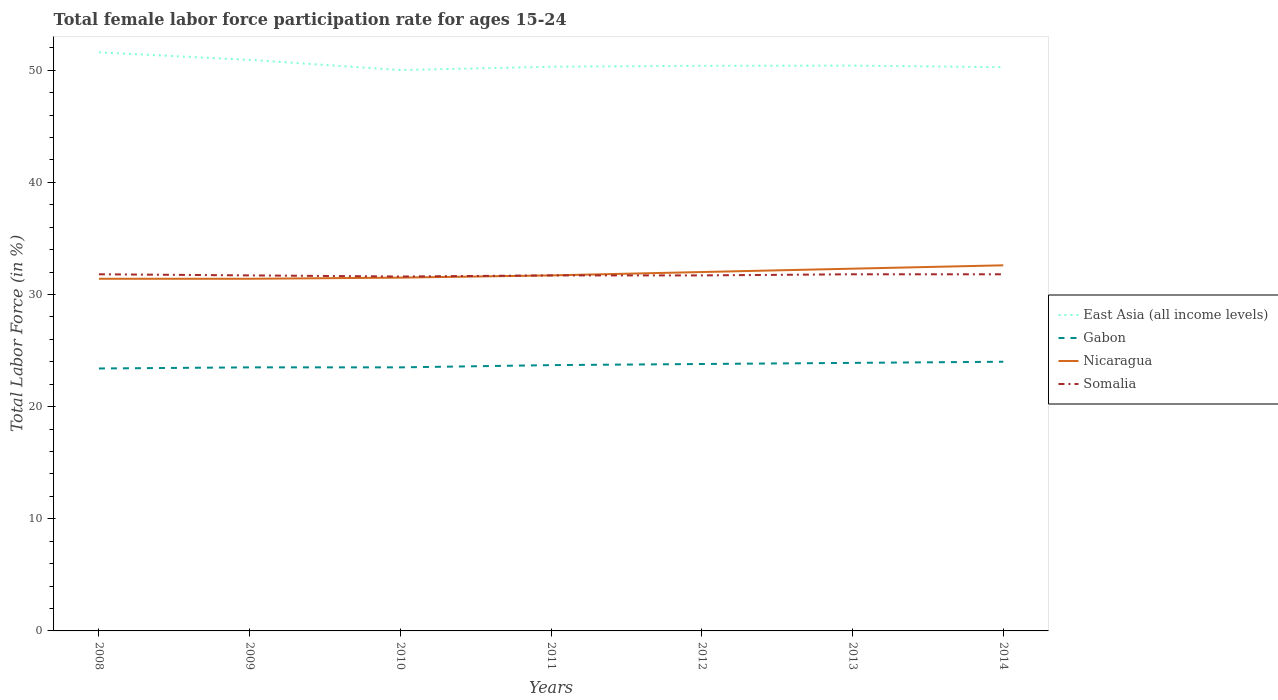Is the number of lines equal to the number of legend labels?
Offer a terse response. Yes. Across all years, what is the maximum female labor force participation rate in East Asia (all income levels)?
Keep it short and to the point. 50.01. In which year was the female labor force participation rate in Gabon maximum?
Make the answer very short. 2008. What is the total female labor force participation rate in East Asia (all income levels) in the graph?
Ensure brevity in your answer.  1.19. What is the difference between the highest and the second highest female labor force participation rate in Somalia?
Keep it short and to the point. 0.2. What is the difference between the highest and the lowest female labor force participation rate in Somalia?
Ensure brevity in your answer.  3. Is the female labor force participation rate in East Asia (all income levels) strictly greater than the female labor force participation rate in Gabon over the years?
Give a very brief answer. No. What is the difference between two consecutive major ticks on the Y-axis?
Offer a terse response. 10. Where does the legend appear in the graph?
Your answer should be compact. Center right. What is the title of the graph?
Make the answer very short. Total female labor force participation rate for ages 15-24. What is the label or title of the X-axis?
Keep it short and to the point. Years. What is the Total Labor Force (in %) in East Asia (all income levels) in 2008?
Offer a very short reply. 51.59. What is the Total Labor Force (in %) in Gabon in 2008?
Offer a very short reply. 23.4. What is the Total Labor Force (in %) in Nicaragua in 2008?
Provide a short and direct response. 31.4. What is the Total Labor Force (in %) in Somalia in 2008?
Keep it short and to the point. 31.8. What is the Total Labor Force (in %) of East Asia (all income levels) in 2009?
Make the answer very short. 50.92. What is the Total Labor Force (in %) of Nicaragua in 2009?
Keep it short and to the point. 31.4. What is the Total Labor Force (in %) in Somalia in 2009?
Your answer should be compact. 31.7. What is the Total Labor Force (in %) in East Asia (all income levels) in 2010?
Ensure brevity in your answer.  50.01. What is the Total Labor Force (in %) in Nicaragua in 2010?
Give a very brief answer. 31.5. What is the Total Labor Force (in %) in Somalia in 2010?
Provide a succinct answer. 31.6. What is the Total Labor Force (in %) of East Asia (all income levels) in 2011?
Offer a very short reply. 50.31. What is the Total Labor Force (in %) in Gabon in 2011?
Make the answer very short. 23.7. What is the Total Labor Force (in %) of Nicaragua in 2011?
Give a very brief answer. 31.7. What is the Total Labor Force (in %) in Somalia in 2011?
Make the answer very short. 31.7. What is the Total Labor Force (in %) in East Asia (all income levels) in 2012?
Ensure brevity in your answer.  50.39. What is the Total Labor Force (in %) in Gabon in 2012?
Offer a very short reply. 23.8. What is the Total Labor Force (in %) of Nicaragua in 2012?
Ensure brevity in your answer.  32. What is the Total Labor Force (in %) of Somalia in 2012?
Give a very brief answer. 31.7. What is the Total Labor Force (in %) of East Asia (all income levels) in 2013?
Your answer should be compact. 50.41. What is the Total Labor Force (in %) of Gabon in 2013?
Ensure brevity in your answer.  23.9. What is the Total Labor Force (in %) in Nicaragua in 2013?
Your answer should be very brief. 32.3. What is the Total Labor Force (in %) of Somalia in 2013?
Ensure brevity in your answer.  31.8. What is the Total Labor Force (in %) in East Asia (all income levels) in 2014?
Ensure brevity in your answer.  50.27. What is the Total Labor Force (in %) of Nicaragua in 2014?
Give a very brief answer. 32.6. What is the Total Labor Force (in %) of Somalia in 2014?
Your answer should be very brief. 31.8. Across all years, what is the maximum Total Labor Force (in %) in East Asia (all income levels)?
Your answer should be very brief. 51.59. Across all years, what is the maximum Total Labor Force (in %) in Nicaragua?
Your answer should be very brief. 32.6. Across all years, what is the maximum Total Labor Force (in %) of Somalia?
Provide a succinct answer. 31.8. Across all years, what is the minimum Total Labor Force (in %) of East Asia (all income levels)?
Offer a very short reply. 50.01. Across all years, what is the minimum Total Labor Force (in %) of Gabon?
Make the answer very short. 23.4. Across all years, what is the minimum Total Labor Force (in %) of Nicaragua?
Give a very brief answer. 31.4. Across all years, what is the minimum Total Labor Force (in %) in Somalia?
Offer a very short reply. 31.6. What is the total Total Labor Force (in %) in East Asia (all income levels) in the graph?
Make the answer very short. 353.88. What is the total Total Labor Force (in %) in Gabon in the graph?
Your response must be concise. 165.8. What is the total Total Labor Force (in %) of Nicaragua in the graph?
Give a very brief answer. 222.9. What is the total Total Labor Force (in %) in Somalia in the graph?
Provide a succinct answer. 222.1. What is the difference between the Total Labor Force (in %) in East Asia (all income levels) in 2008 and that in 2009?
Give a very brief answer. 0.67. What is the difference between the Total Labor Force (in %) in Gabon in 2008 and that in 2009?
Provide a succinct answer. -0.1. What is the difference between the Total Labor Force (in %) in Somalia in 2008 and that in 2009?
Your answer should be very brief. 0.1. What is the difference between the Total Labor Force (in %) of East Asia (all income levels) in 2008 and that in 2010?
Offer a terse response. 1.58. What is the difference between the Total Labor Force (in %) of Gabon in 2008 and that in 2010?
Your answer should be very brief. -0.1. What is the difference between the Total Labor Force (in %) in East Asia (all income levels) in 2008 and that in 2011?
Offer a very short reply. 1.28. What is the difference between the Total Labor Force (in %) of Gabon in 2008 and that in 2011?
Your answer should be compact. -0.3. What is the difference between the Total Labor Force (in %) of Nicaragua in 2008 and that in 2011?
Your answer should be very brief. -0.3. What is the difference between the Total Labor Force (in %) in East Asia (all income levels) in 2008 and that in 2012?
Offer a terse response. 1.19. What is the difference between the Total Labor Force (in %) of Nicaragua in 2008 and that in 2012?
Give a very brief answer. -0.6. What is the difference between the Total Labor Force (in %) in Somalia in 2008 and that in 2012?
Offer a terse response. 0.1. What is the difference between the Total Labor Force (in %) of East Asia (all income levels) in 2008 and that in 2013?
Your response must be concise. 1.18. What is the difference between the Total Labor Force (in %) of Somalia in 2008 and that in 2013?
Give a very brief answer. 0. What is the difference between the Total Labor Force (in %) in East Asia (all income levels) in 2008 and that in 2014?
Offer a terse response. 1.32. What is the difference between the Total Labor Force (in %) in Gabon in 2008 and that in 2014?
Your response must be concise. -0.6. What is the difference between the Total Labor Force (in %) of Nicaragua in 2008 and that in 2014?
Provide a short and direct response. -1.2. What is the difference between the Total Labor Force (in %) in East Asia (all income levels) in 2009 and that in 2010?
Give a very brief answer. 0.91. What is the difference between the Total Labor Force (in %) in Nicaragua in 2009 and that in 2010?
Offer a very short reply. -0.1. What is the difference between the Total Labor Force (in %) of East Asia (all income levels) in 2009 and that in 2011?
Make the answer very short. 0.61. What is the difference between the Total Labor Force (in %) of East Asia (all income levels) in 2009 and that in 2012?
Your answer should be very brief. 0.53. What is the difference between the Total Labor Force (in %) of Gabon in 2009 and that in 2012?
Your response must be concise. -0.3. What is the difference between the Total Labor Force (in %) of Somalia in 2009 and that in 2012?
Your answer should be compact. 0. What is the difference between the Total Labor Force (in %) of East Asia (all income levels) in 2009 and that in 2013?
Ensure brevity in your answer.  0.51. What is the difference between the Total Labor Force (in %) in Gabon in 2009 and that in 2013?
Your answer should be very brief. -0.4. What is the difference between the Total Labor Force (in %) in Somalia in 2009 and that in 2013?
Your response must be concise. -0.1. What is the difference between the Total Labor Force (in %) of East Asia (all income levels) in 2009 and that in 2014?
Provide a succinct answer. 0.65. What is the difference between the Total Labor Force (in %) of Gabon in 2009 and that in 2014?
Ensure brevity in your answer.  -0.5. What is the difference between the Total Labor Force (in %) of Somalia in 2009 and that in 2014?
Provide a succinct answer. -0.1. What is the difference between the Total Labor Force (in %) in East Asia (all income levels) in 2010 and that in 2011?
Provide a succinct answer. -0.3. What is the difference between the Total Labor Force (in %) of Gabon in 2010 and that in 2011?
Your answer should be very brief. -0.2. What is the difference between the Total Labor Force (in %) of East Asia (all income levels) in 2010 and that in 2012?
Offer a very short reply. -0.38. What is the difference between the Total Labor Force (in %) of Somalia in 2010 and that in 2012?
Keep it short and to the point. -0.1. What is the difference between the Total Labor Force (in %) of East Asia (all income levels) in 2010 and that in 2013?
Provide a succinct answer. -0.4. What is the difference between the Total Labor Force (in %) of Gabon in 2010 and that in 2013?
Give a very brief answer. -0.4. What is the difference between the Total Labor Force (in %) of Nicaragua in 2010 and that in 2013?
Your response must be concise. -0.8. What is the difference between the Total Labor Force (in %) in Somalia in 2010 and that in 2013?
Give a very brief answer. -0.2. What is the difference between the Total Labor Force (in %) in East Asia (all income levels) in 2010 and that in 2014?
Keep it short and to the point. -0.26. What is the difference between the Total Labor Force (in %) in Nicaragua in 2010 and that in 2014?
Ensure brevity in your answer.  -1.1. What is the difference between the Total Labor Force (in %) of East Asia (all income levels) in 2011 and that in 2012?
Your answer should be compact. -0.09. What is the difference between the Total Labor Force (in %) of Nicaragua in 2011 and that in 2012?
Your answer should be compact. -0.3. What is the difference between the Total Labor Force (in %) in Somalia in 2011 and that in 2012?
Ensure brevity in your answer.  0. What is the difference between the Total Labor Force (in %) in East Asia (all income levels) in 2011 and that in 2013?
Your answer should be compact. -0.1. What is the difference between the Total Labor Force (in %) of Nicaragua in 2011 and that in 2013?
Keep it short and to the point. -0.6. What is the difference between the Total Labor Force (in %) of Somalia in 2011 and that in 2013?
Keep it short and to the point. -0.1. What is the difference between the Total Labor Force (in %) of East Asia (all income levels) in 2011 and that in 2014?
Your answer should be compact. 0.04. What is the difference between the Total Labor Force (in %) in Somalia in 2011 and that in 2014?
Offer a very short reply. -0.1. What is the difference between the Total Labor Force (in %) in East Asia (all income levels) in 2012 and that in 2013?
Keep it short and to the point. -0.02. What is the difference between the Total Labor Force (in %) in Gabon in 2012 and that in 2013?
Provide a short and direct response. -0.1. What is the difference between the Total Labor Force (in %) in Somalia in 2012 and that in 2013?
Offer a very short reply. -0.1. What is the difference between the Total Labor Force (in %) in East Asia (all income levels) in 2012 and that in 2014?
Offer a terse response. 0.12. What is the difference between the Total Labor Force (in %) in Gabon in 2012 and that in 2014?
Ensure brevity in your answer.  -0.2. What is the difference between the Total Labor Force (in %) in East Asia (all income levels) in 2013 and that in 2014?
Your response must be concise. 0.14. What is the difference between the Total Labor Force (in %) in Gabon in 2013 and that in 2014?
Offer a terse response. -0.1. What is the difference between the Total Labor Force (in %) in Somalia in 2013 and that in 2014?
Your answer should be very brief. 0. What is the difference between the Total Labor Force (in %) of East Asia (all income levels) in 2008 and the Total Labor Force (in %) of Gabon in 2009?
Ensure brevity in your answer.  28.09. What is the difference between the Total Labor Force (in %) in East Asia (all income levels) in 2008 and the Total Labor Force (in %) in Nicaragua in 2009?
Your answer should be very brief. 20.19. What is the difference between the Total Labor Force (in %) in East Asia (all income levels) in 2008 and the Total Labor Force (in %) in Somalia in 2009?
Ensure brevity in your answer.  19.89. What is the difference between the Total Labor Force (in %) in Gabon in 2008 and the Total Labor Force (in %) in Somalia in 2009?
Give a very brief answer. -8.3. What is the difference between the Total Labor Force (in %) in Nicaragua in 2008 and the Total Labor Force (in %) in Somalia in 2009?
Your answer should be compact. -0.3. What is the difference between the Total Labor Force (in %) in East Asia (all income levels) in 2008 and the Total Labor Force (in %) in Gabon in 2010?
Your answer should be very brief. 28.09. What is the difference between the Total Labor Force (in %) in East Asia (all income levels) in 2008 and the Total Labor Force (in %) in Nicaragua in 2010?
Your response must be concise. 20.09. What is the difference between the Total Labor Force (in %) of East Asia (all income levels) in 2008 and the Total Labor Force (in %) of Somalia in 2010?
Offer a very short reply. 19.99. What is the difference between the Total Labor Force (in %) of East Asia (all income levels) in 2008 and the Total Labor Force (in %) of Gabon in 2011?
Keep it short and to the point. 27.89. What is the difference between the Total Labor Force (in %) in East Asia (all income levels) in 2008 and the Total Labor Force (in %) in Nicaragua in 2011?
Provide a succinct answer. 19.89. What is the difference between the Total Labor Force (in %) in East Asia (all income levels) in 2008 and the Total Labor Force (in %) in Somalia in 2011?
Your answer should be very brief. 19.89. What is the difference between the Total Labor Force (in %) in Gabon in 2008 and the Total Labor Force (in %) in Nicaragua in 2011?
Ensure brevity in your answer.  -8.3. What is the difference between the Total Labor Force (in %) of Nicaragua in 2008 and the Total Labor Force (in %) of Somalia in 2011?
Make the answer very short. -0.3. What is the difference between the Total Labor Force (in %) in East Asia (all income levels) in 2008 and the Total Labor Force (in %) in Gabon in 2012?
Your answer should be compact. 27.79. What is the difference between the Total Labor Force (in %) in East Asia (all income levels) in 2008 and the Total Labor Force (in %) in Nicaragua in 2012?
Your response must be concise. 19.59. What is the difference between the Total Labor Force (in %) of East Asia (all income levels) in 2008 and the Total Labor Force (in %) of Somalia in 2012?
Give a very brief answer. 19.89. What is the difference between the Total Labor Force (in %) of Nicaragua in 2008 and the Total Labor Force (in %) of Somalia in 2012?
Provide a short and direct response. -0.3. What is the difference between the Total Labor Force (in %) of East Asia (all income levels) in 2008 and the Total Labor Force (in %) of Gabon in 2013?
Offer a terse response. 27.69. What is the difference between the Total Labor Force (in %) of East Asia (all income levels) in 2008 and the Total Labor Force (in %) of Nicaragua in 2013?
Offer a very short reply. 19.29. What is the difference between the Total Labor Force (in %) in East Asia (all income levels) in 2008 and the Total Labor Force (in %) in Somalia in 2013?
Ensure brevity in your answer.  19.79. What is the difference between the Total Labor Force (in %) in Nicaragua in 2008 and the Total Labor Force (in %) in Somalia in 2013?
Keep it short and to the point. -0.4. What is the difference between the Total Labor Force (in %) of East Asia (all income levels) in 2008 and the Total Labor Force (in %) of Gabon in 2014?
Offer a very short reply. 27.59. What is the difference between the Total Labor Force (in %) of East Asia (all income levels) in 2008 and the Total Labor Force (in %) of Nicaragua in 2014?
Give a very brief answer. 18.99. What is the difference between the Total Labor Force (in %) of East Asia (all income levels) in 2008 and the Total Labor Force (in %) of Somalia in 2014?
Make the answer very short. 19.79. What is the difference between the Total Labor Force (in %) in East Asia (all income levels) in 2009 and the Total Labor Force (in %) in Gabon in 2010?
Your answer should be very brief. 27.42. What is the difference between the Total Labor Force (in %) of East Asia (all income levels) in 2009 and the Total Labor Force (in %) of Nicaragua in 2010?
Your response must be concise. 19.42. What is the difference between the Total Labor Force (in %) of East Asia (all income levels) in 2009 and the Total Labor Force (in %) of Somalia in 2010?
Provide a succinct answer. 19.32. What is the difference between the Total Labor Force (in %) in Gabon in 2009 and the Total Labor Force (in %) in Nicaragua in 2010?
Ensure brevity in your answer.  -8. What is the difference between the Total Labor Force (in %) in East Asia (all income levels) in 2009 and the Total Labor Force (in %) in Gabon in 2011?
Provide a succinct answer. 27.22. What is the difference between the Total Labor Force (in %) of East Asia (all income levels) in 2009 and the Total Labor Force (in %) of Nicaragua in 2011?
Offer a very short reply. 19.22. What is the difference between the Total Labor Force (in %) in East Asia (all income levels) in 2009 and the Total Labor Force (in %) in Somalia in 2011?
Your response must be concise. 19.22. What is the difference between the Total Labor Force (in %) in Gabon in 2009 and the Total Labor Force (in %) in Somalia in 2011?
Your response must be concise. -8.2. What is the difference between the Total Labor Force (in %) in Nicaragua in 2009 and the Total Labor Force (in %) in Somalia in 2011?
Provide a succinct answer. -0.3. What is the difference between the Total Labor Force (in %) in East Asia (all income levels) in 2009 and the Total Labor Force (in %) in Gabon in 2012?
Give a very brief answer. 27.12. What is the difference between the Total Labor Force (in %) of East Asia (all income levels) in 2009 and the Total Labor Force (in %) of Nicaragua in 2012?
Your answer should be compact. 18.92. What is the difference between the Total Labor Force (in %) of East Asia (all income levels) in 2009 and the Total Labor Force (in %) of Somalia in 2012?
Ensure brevity in your answer.  19.22. What is the difference between the Total Labor Force (in %) of Gabon in 2009 and the Total Labor Force (in %) of Nicaragua in 2012?
Make the answer very short. -8.5. What is the difference between the Total Labor Force (in %) in Nicaragua in 2009 and the Total Labor Force (in %) in Somalia in 2012?
Keep it short and to the point. -0.3. What is the difference between the Total Labor Force (in %) of East Asia (all income levels) in 2009 and the Total Labor Force (in %) of Gabon in 2013?
Make the answer very short. 27.02. What is the difference between the Total Labor Force (in %) of East Asia (all income levels) in 2009 and the Total Labor Force (in %) of Nicaragua in 2013?
Offer a terse response. 18.62. What is the difference between the Total Labor Force (in %) in East Asia (all income levels) in 2009 and the Total Labor Force (in %) in Somalia in 2013?
Offer a very short reply. 19.12. What is the difference between the Total Labor Force (in %) in Gabon in 2009 and the Total Labor Force (in %) in Nicaragua in 2013?
Your answer should be compact. -8.8. What is the difference between the Total Labor Force (in %) in East Asia (all income levels) in 2009 and the Total Labor Force (in %) in Gabon in 2014?
Provide a succinct answer. 26.92. What is the difference between the Total Labor Force (in %) in East Asia (all income levels) in 2009 and the Total Labor Force (in %) in Nicaragua in 2014?
Give a very brief answer. 18.32. What is the difference between the Total Labor Force (in %) of East Asia (all income levels) in 2009 and the Total Labor Force (in %) of Somalia in 2014?
Provide a succinct answer. 19.12. What is the difference between the Total Labor Force (in %) in Gabon in 2009 and the Total Labor Force (in %) in Nicaragua in 2014?
Your answer should be compact. -9.1. What is the difference between the Total Labor Force (in %) of East Asia (all income levels) in 2010 and the Total Labor Force (in %) of Gabon in 2011?
Give a very brief answer. 26.31. What is the difference between the Total Labor Force (in %) of East Asia (all income levels) in 2010 and the Total Labor Force (in %) of Nicaragua in 2011?
Provide a short and direct response. 18.31. What is the difference between the Total Labor Force (in %) in East Asia (all income levels) in 2010 and the Total Labor Force (in %) in Somalia in 2011?
Offer a very short reply. 18.31. What is the difference between the Total Labor Force (in %) of Gabon in 2010 and the Total Labor Force (in %) of Nicaragua in 2011?
Give a very brief answer. -8.2. What is the difference between the Total Labor Force (in %) of East Asia (all income levels) in 2010 and the Total Labor Force (in %) of Gabon in 2012?
Provide a short and direct response. 26.21. What is the difference between the Total Labor Force (in %) in East Asia (all income levels) in 2010 and the Total Labor Force (in %) in Nicaragua in 2012?
Provide a succinct answer. 18.01. What is the difference between the Total Labor Force (in %) of East Asia (all income levels) in 2010 and the Total Labor Force (in %) of Somalia in 2012?
Your answer should be very brief. 18.31. What is the difference between the Total Labor Force (in %) in Gabon in 2010 and the Total Labor Force (in %) in Nicaragua in 2012?
Your response must be concise. -8.5. What is the difference between the Total Labor Force (in %) of Gabon in 2010 and the Total Labor Force (in %) of Somalia in 2012?
Your answer should be very brief. -8.2. What is the difference between the Total Labor Force (in %) in East Asia (all income levels) in 2010 and the Total Labor Force (in %) in Gabon in 2013?
Provide a short and direct response. 26.11. What is the difference between the Total Labor Force (in %) in East Asia (all income levels) in 2010 and the Total Labor Force (in %) in Nicaragua in 2013?
Provide a short and direct response. 17.71. What is the difference between the Total Labor Force (in %) of East Asia (all income levels) in 2010 and the Total Labor Force (in %) of Somalia in 2013?
Your answer should be compact. 18.21. What is the difference between the Total Labor Force (in %) of Gabon in 2010 and the Total Labor Force (in %) of Nicaragua in 2013?
Ensure brevity in your answer.  -8.8. What is the difference between the Total Labor Force (in %) of Nicaragua in 2010 and the Total Labor Force (in %) of Somalia in 2013?
Make the answer very short. -0.3. What is the difference between the Total Labor Force (in %) in East Asia (all income levels) in 2010 and the Total Labor Force (in %) in Gabon in 2014?
Make the answer very short. 26.01. What is the difference between the Total Labor Force (in %) of East Asia (all income levels) in 2010 and the Total Labor Force (in %) of Nicaragua in 2014?
Make the answer very short. 17.41. What is the difference between the Total Labor Force (in %) of East Asia (all income levels) in 2010 and the Total Labor Force (in %) of Somalia in 2014?
Your response must be concise. 18.21. What is the difference between the Total Labor Force (in %) in Gabon in 2010 and the Total Labor Force (in %) in Nicaragua in 2014?
Offer a terse response. -9.1. What is the difference between the Total Labor Force (in %) in East Asia (all income levels) in 2011 and the Total Labor Force (in %) in Gabon in 2012?
Your answer should be compact. 26.51. What is the difference between the Total Labor Force (in %) in East Asia (all income levels) in 2011 and the Total Labor Force (in %) in Nicaragua in 2012?
Make the answer very short. 18.31. What is the difference between the Total Labor Force (in %) in East Asia (all income levels) in 2011 and the Total Labor Force (in %) in Somalia in 2012?
Make the answer very short. 18.61. What is the difference between the Total Labor Force (in %) of Gabon in 2011 and the Total Labor Force (in %) of Nicaragua in 2012?
Ensure brevity in your answer.  -8.3. What is the difference between the Total Labor Force (in %) in Nicaragua in 2011 and the Total Labor Force (in %) in Somalia in 2012?
Offer a terse response. 0. What is the difference between the Total Labor Force (in %) of East Asia (all income levels) in 2011 and the Total Labor Force (in %) of Gabon in 2013?
Give a very brief answer. 26.41. What is the difference between the Total Labor Force (in %) in East Asia (all income levels) in 2011 and the Total Labor Force (in %) in Nicaragua in 2013?
Give a very brief answer. 18.01. What is the difference between the Total Labor Force (in %) in East Asia (all income levels) in 2011 and the Total Labor Force (in %) in Somalia in 2013?
Your answer should be compact. 18.51. What is the difference between the Total Labor Force (in %) of Gabon in 2011 and the Total Labor Force (in %) of Nicaragua in 2013?
Provide a short and direct response. -8.6. What is the difference between the Total Labor Force (in %) of Nicaragua in 2011 and the Total Labor Force (in %) of Somalia in 2013?
Offer a very short reply. -0.1. What is the difference between the Total Labor Force (in %) of East Asia (all income levels) in 2011 and the Total Labor Force (in %) of Gabon in 2014?
Your answer should be compact. 26.31. What is the difference between the Total Labor Force (in %) in East Asia (all income levels) in 2011 and the Total Labor Force (in %) in Nicaragua in 2014?
Ensure brevity in your answer.  17.71. What is the difference between the Total Labor Force (in %) of East Asia (all income levels) in 2011 and the Total Labor Force (in %) of Somalia in 2014?
Provide a short and direct response. 18.51. What is the difference between the Total Labor Force (in %) in Gabon in 2011 and the Total Labor Force (in %) in Nicaragua in 2014?
Offer a very short reply. -8.9. What is the difference between the Total Labor Force (in %) of Nicaragua in 2011 and the Total Labor Force (in %) of Somalia in 2014?
Make the answer very short. -0.1. What is the difference between the Total Labor Force (in %) in East Asia (all income levels) in 2012 and the Total Labor Force (in %) in Gabon in 2013?
Give a very brief answer. 26.49. What is the difference between the Total Labor Force (in %) of East Asia (all income levels) in 2012 and the Total Labor Force (in %) of Nicaragua in 2013?
Your response must be concise. 18.09. What is the difference between the Total Labor Force (in %) of East Asia (all income levels) in 2012 and the Total Labor Force (in %) of Somalia in 2013?
Provide a short and direct response. 18.59. What is the difference between the Total Labor Force (in %) of Gabon in 2012 and the Total Labor Force (in %) of Nicaragua in 2013?
Keep it short and to the point. -8.5. What is the difference between the Total Labor Force (in %) of Gabon in 2012 and the Total Labor Force (in %) of Somalia in 2013?
Offer a terse response. -8. What is the difference between the Total Labor Force (in %) in East Asia (all income levels) in 2012 and the Total Labor Force (in %) in Gabon in 2014?
Provide a succinct answer. 26.39. What is the difference between the Total Labor Force (in %) in East Asia (all income levels) in 2012 and the Total Labor Force (in %) in Nicaragua in 2014?
Offer a very short reply. 17.79. What is the difference between the Total Labor Force (in %) in East Asia (all income levels) in 2012 and the Total Labor Force (in %) in Somalia in 2014?
Offer a terse response. 18.59. What is the difference between the Total Labor Force (in %) in Gabon in 2012 and the Total Labor Force (in %) in Somalia in 2014?
Your response must be concise. -8. What is the difference between the Total Labor Force (in %) in East Asia (all income levels) in 2013 and the Total Labor Force (in %) in Gabon in 2014?
Make the answer very short. 26.41. What is the difference between the Total Labor Force (in %) of East Asia (all income levels) in 2013 and the Total Labor Force (in %) of Nicaragua in 2014?
Provide a succinct answer. 17.81. What is the difference between the Total Labor Force (in %) in East Asia (all income levels) in 2013 and the Total Labor Force (in %) in Somalia in 2014?
Keep it short and to the point. 18.61. What is the difference between the Total Labor Force (in %) in Gabon in 2013 and the Total Labor Force (in %) in Nicaragua in 2014?
Offer a very short reply. -8.7. What is the average Total Labor Force (in %) of East Asia (all income levels) per year?
Ensure brevity in your answer.  50.55. What is the average Total Labor Force (in %) in Gabon per year?
Offer a very short reply. 23.69. What is the average Total Labor Force (in %) of Nicaragua per year?
Provide a short and direct response. 31.84. What is the average Total Labor Force (in %) in Somalia per year?
Give a very brief answer. 31.73. In the year 2008, what is the difference between the Total Labor Force (in %) of East Asia (all income levels) and Total Labor Force (in %) of Gabon?
Your answer should be compact. 28.19. In the year 2008, what is the difference between the Total Labor Force (in %) of East Asia (all income levels) and Total Labor Force (in %) of Nicaragua?
Give a very brief answer. 20.19. In the year 2008, what is the difference between the Total Labor Force (in %) in East Asia (all income levels) and Total Labor Force (in %) in Somalia?
Your response must be concise. 19.79. In the year 2008, what is the difference between the Total Labor Force (in %) in Gabon and Total Labor Force (in %) in Somalia?
Ensure brevity in your answer.  -8.4. In the year 2008, what is the difference between the Total Labor Force (in %) of Nicaragua and Total Labor Force (in %) of Somalia?
Provide a succinct answer. -0.4. In the year 2009, what is the difference between the Total Labor Force (in %) of East Asia (all income levels) and Total Labor Force (in %) of Gabon?
Keep it short and to the point. 27.42. In the year 2009, what is the difference between the Total Labor Force (in %) of East Asia (all income levels) and Total Labor Force (in %) of Nicaragua?
Offer a very short reply. 19.52. In the year 2009, what is the difference between the Total Labor Force (in %) of East Asia (all income levels) and Total Labor Force (in %) of Somalia?
Make the answer very short. 19.22. In the year 2009, what is the difference between the Total Labor Force (in %) in Gabon and Total Labor Force (in %) in Somalia?
Give a very brief answer. -8.2. In the year 2009, what is the difference between the Total Labor Force (in %) of Nicaragua and Total Labor Force (in %) of Somalia?
Offer a terse response. -0.3. In the year 2010, what is the difference between the Total Labor Force (in %) in East Asia (all income levels) and Total Labor Force (in %) in Gabon?
Your answer should be compact. 26.51. In the year 2010, what is the difference between the Total Labor Force (in %) in East Asia (all income levels) and Total Labor Force (in %) in Nicaragua?
Ensure brevity in your answer.  18.51. In the year 2010, what is the difference between the Total Labor Force (in %) of East Asia (all income levels) and Total Labor Force (in %) of Somalia?
Offer a terse response. 18.41. In the year 2010, what is the difference between the Total Labor Force (in %) in Nicaragua and Total Labor Force (in %) in Somalia?
Give a very brief answer. -0.1. In the year 2011, what is the difference between the Total Labor Force (in %) of East Asia (all income levels) and Total Labor Force (in %) of Gabon?
Keep it short and to the point. 26.61. In the year 2011, what is the difference between the Total Labor Force (in %) of East Asia (all income levels) and Total Labor Force (in %) of Nicaragua?
Your answer should be compact. 18.61. In the year 2011, what is the difference between the Total Labor Force (in %) of East Asia (all income levels) and Total Labor Force (in %) of Somalia?
Give a very brief answer. 18.61. In the year 2011, what is the difference between the Total Labor Force (in %) in Gabon and Total Labor Force (in %) in Nicaragua?
Ensure brevity in your answer.  -8. In the year 2011, what is the difference between the Total Labor Force (in %) of Gabon and Total Labor Force (in %) of Somalia?
Ensure brevity in your answer.  -8. In the year 2012, what is the difference between the Total Labor Force (in %) of East Asia (all income levels) and Total Labor Force (in %) of Gabon?
Give a very brief answer. 26.59. In the year 2012, what is the difference between the Total Labor Force (in %) of East Asia (all income levels) and Total Labor Force (in %) of Nicaragua?
Your answer should be compact. 18.39. In the year 2012, what is the difference between the Total Labor Force (in %) in East Asia (all income levels) and Total Labor Force (in %) in Somalia?
Your answer should be compact. 18.69. In the year 2012, what is the difference between the Total Labor Force (in %) in Nicaragua and Total Labor Force (in %) in Somalia?
Your answer should be compact. 0.3. In the year 2013, what is the difference between the Total Labor Force (in %) of East Asia (all income levels) and Total Labor Force (in %) of Gabon?
Make the answer very short. 26.51. In the year 2013, what is the difference between the Total Labor Force (in %) in East Asia (all income levels) and Total Labor Force (in %) in Nicaragua?
Offer a terse response. 18.11. In the year 2013, what is the difference between the Total Labor Force (in %) of East Asia (all income levels) and Total Labor Force (in %) of Somalia?
Your response must be concise. 18.61. In the year 2013, what is the difference between the Total Labor Force (in %) of Gabon and Total Labor Force (in %) of Nicaragua?
Ensure brevity in your answer.  -8.4. In the year 2014, what is the difference between the Total Labor Force (in %) of East Asia (all income levels) and Total Labor Force (in %) of Gabon?
Ensure brevity in your answer.  26.27. In the year 2014, what is the difference between the Total Labor Force (in %) in East Asia (all income levels) and Total Labor Force (in %) in Nicaragua?
Provide a short and direct response. 17.67. In the year 2014, what is the difference between the Total Labor Force (in %) of East Asia (all income levels) and Total Labor Force (in %) of Somalia?
Provide a short and direct response. 18.47. In the year 2014, what is the difference between the Total Labor Force (in %) of Gabon and Total Labor Force (in %) of Nicaragua?
Give a very brief answer. -8.6. What is the ratio of the Total Labor Force (in %) in East Asia (all income levels) in 2008 to that in 2009?
Give a very brief answer. 1.01. What is the ratio of the Total Labor Force (in %) in Nicaragua in 2008 to that in 2009?
Keep it short and to the point. 1. What is the ratio of the Total Labor Force (in %) in Somalia in 2008 to that in 2009?
Your answer should be compact. 1. What is the ratio of the Total Labor Force (in %) of East Asia (all income levels) in 2008 to that in 2010?
Your answer should be very brief. 1.03. What is the ratio of the Total Labor Force (in %) in Gabon in 2008 to that in 2010?
Offer a terse response. 1. What is the ratio of the Total Labor Force (in %) of East Asia (all income levels) in 2008 to that in 2011?
Your answer should be very brief. 1.03. What is the ratio of the Total Labor Force (in %) in Gabon in 2008 to that in 2011?
Provide a succinct answer. 0.99. What is the ratio of the Total Labor Force (in %) of Somalia in 2008 to that in 2011?
Your response must be concise. 1. What is the ratio of the Total Labor Force (in %) in East Asia (all income levels) in 2008 to that in 2012?
Your answer should be very brief. 1.02. What is the ratio of the Total Labor Force (in %) of Gabon in 2008 to that in 2012?
Provide a succinct answer. 0.98. What is the ratio of the Total Labor Force (in %) of Nicaragua in 2008 to that in 2012?
Provide a short and direct response. 0.98. What is the ratio of the Total Labor Force (in %) in East Asia (all income levels) in 2008 to that in 2013?
Your response must be concise. 1.02. What is the ratio of the Total Labor Force (in %) in Gabon in 2008 to that in 2013?
Keep it short and to the point. 0.98. What is the ratio of the Total Labor Force (in %) in Nicaragua in 2008 to that in 2013?
Your answer should be compact. 0.97. What is the ratio of the Total Labor Force (in %) in Somalia in 2008 to that in 2013?
Your response must be concise. 1. What is the ratio of the Total Labor Force (in %) in East Asia (all income levels) in 2008 to that in 2014?
Offer a very short reply. 1.03. What is the ratio of the Total Labor Force (in %) of Gabon in 2008 to that in 2014?
Ensure brevity in your answer.  0.97. What is the ratio of the Total Labor Force (in %) of Nicaragua in 2008 to that in 2014?
Offer a very short reply. 0.96. What is the ratio of the Total Labor Force (in %) in Somalia in 2008 to that in 2014?
Provide a succinct answer. 1. What is the ratio of the Total Labor Force (in %) in East Asia (all income levels) in 2009 to that in 2010?
Your answer should be very brief. 1.02. What is the ratio of the Total Labor Force (in %) of East Asia (all income levels) in 2009 to that in 2011?
Offer a terse response. 1.01. What is the ratio of the Total Labor Force (in %) of Nicaragua in 2009 to that in 2011?
Your response must be concise. 0.99. What is the ratio of the Total Labor Force (in %) in East Asia (all income levels) in 2009 to that in 2012?
Provide a short and direct response. 1.01. What is the ratio of the Total Labor Force (in %) of Gabon in 2009 to that in 2012?
Give a very brief answer. 0.99. What is the ratio of the Total Labor Force (in %) of Nicaragua in 2009 to that in 2012?
Offer a very short reply. 0.98. What is the ratio of the Total Labor Force (in %) of Somalia in 2009 to that in 2012?
Provide a succinct answer. 1. What is the ratio of the Total Labor Force (in %) in East Asia (all income levels) in 2009 to that in 2013?
Provide a short and direct response. 1.01. What is the ratio of the Total Labor Force (in %) of Gabon in 2009 to that in 2013?
Offer a very short reply. 0.98. What is the ratio of the Total Labor Force (in %) of Nicaragua in 2009 to that in 2013?
Your answer should be compact. 0.97. What is the ratio of the Total Labor Force (in %) of East Asia (all income levels) in 2009 to that in 2014?
Make the answer very short. 1.01. What is the ratio of the Total Labor Force (in %) in Gabon in 2009 to that in 2014?
Your response must be concise. 0.98. What is the ratio of the Total Labor Force (in %) of Nicaragua in 2009 to that in 2014?
Your answer should be compact. 0.96. What is the ratio of the Total Labor Force (in %) of Somalia in 2010 to that in 2011?
Make the answer very short. 1. What is the ratio of the Total Labor Force (in %) of East Asia (all income levels) in 2010 to that in 2012?
Give a very brief answer. 0.99. What is the ratio of the Total Labor Force (in %) in Gabon in 2010 to that in 2012?
Your answer should be compact. 0.99. What is the ratio of the Total Labor Force (in %) of Nicaragua in 2010 to that in 2012?
Keep it short and to the point. 0.98. What is the ratio of the Total Labor Force (in %) in Gabon in 2010 to that in 2013?
Offer a terse response. 0.98. What is the ratio of the Total Labor Force (in %) of Nicaragua in 2010 to that in 2013?
Provide a short and direct response. 0.98. What is the ratio of the Total Labor Force (in %) in Somalia in 2010 to that in 2013?
Your response must be concise. 0.99. What is the ratio of the Total Labor Force (in %) in East Asia (all income levels) in 2010 to that in 2014?
Make the answer very short. 0.99. What is the ratio of the Total Labor Force (in %) in Gabon in 2010 to that in 2014?
Provide a succinct answer. 0.98. What is the ratio of the Total Labor Force (in %) in Nicaragua in 2010 to that in 2014?
Ensure brevity in your answer.  0.97. What is the ratio of the Total Labor Force (in %) in Somalia in 2010 to that in 2014?
Provide a short and direct response. 0.99. What is the ratio of the Total Labor Force (in %) in Gabon in 2011 to that in 2012?
Your response must be concise. 1. What is the ratio of the Total Labor Force (in %) in Nicaragua in 2011 to that in 2012?
Provide a short and direct response. 0.99. What is the ratio of the Total Labor Force (in %) in Somalia in 2011 to that in 2012?
Offer a very short reply. 1. What is the ratio of the Total Labor Force (in %) of Gabon in 2011 to that in 2013?
Give a very brief answer. 0.99. What is the ratio of the Total Labor Force (in %) in Nicaragua in 2011 to that in 2013?
Offer a terse response. 0.98. What is the ratio of the Total Labor Force (in %) of Somalia in 2011 to that in 2013?
Your answer should be compact. 1. What is the ratio of the Total Labor Force (in %) in Gabon in 2011 to that in 2014?
Keep it short and to the point. 0.99. What is the ratio of the Total Labor Force (in %) in Nicaragua in 2011 to that in 2014?
Offer a terse response. 0.97. What is the ratio of the Total Labor Force (in %) in Somalia in 2011 to that in 2014?
Your answer should be compact. 1. What is the ratio of the Total Labor Force (in %) in East Asia (all income levels) in 2012 to that in 2014?
Keep it short and to the point. 1. What is the ratio of the Total Labor Force (in %) of Nicaragua in 2012 to that in 2014?
Keep it short and to the point. 0.98. What is the ratio of the Total Labor Force (in %) in East Asia (all income levels) in 2013 to that in 2014?
Offer a very short reply. 1. What is the ratio of the Total Labor Force (in %) of Gabon in 2013 to that in 2014?
Make the answer very short. 1. What is the difference between the highest and the second highest Total Labor Force (in %) of East Asia (all income levels)?
Give a very brief answer. 0.67. What is the difference between the highest and the lowest Total Labor Force (in %) of East Asia (all income levels)?
Your answer should be compact. 1.58. What is the difference between the highest and the lowest Total Labor Force (in %) of Gabon?
Your response must be concise. 0.6. What is the difference between the highest and the lowest Total Labor Force (in %) of Nicaragua?
Offer a terse response. 1.2. 